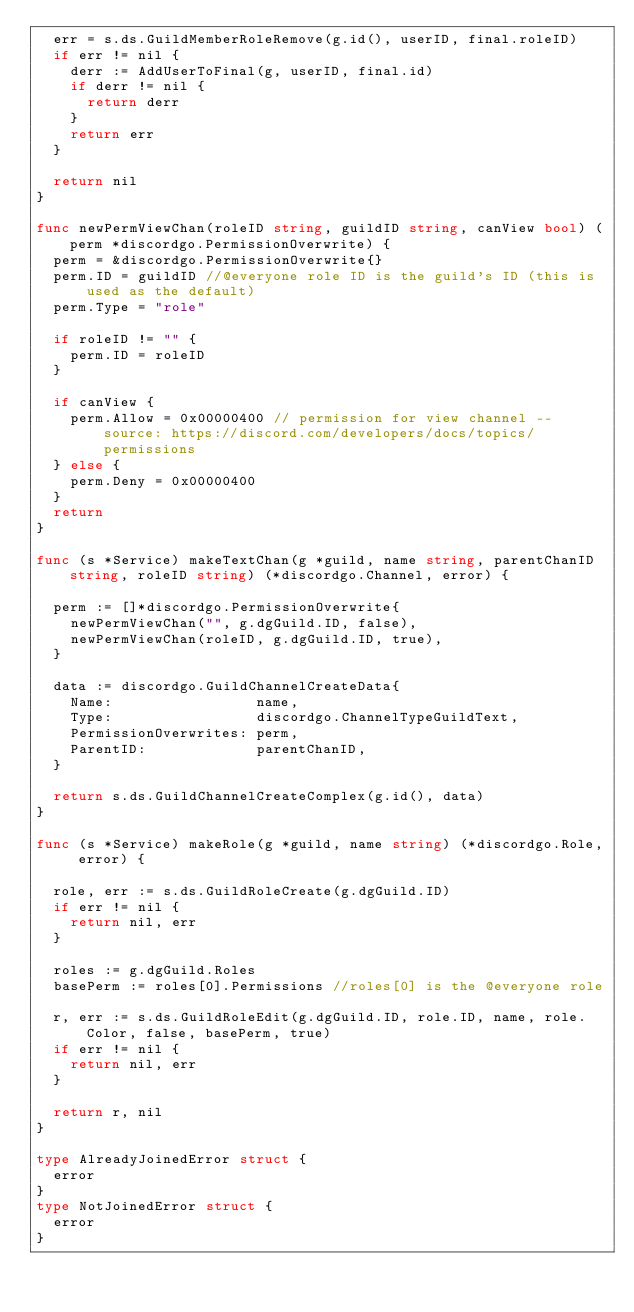Convert code to text. <code><loc_0><loc_0><loc_500><loc_500><_Go_>	err = s.ds.GuildMemberRoleRemove(g.id(), userID, final.roleID)
	if err != nil {
		derr := AddUserToFinal(g, userID, final.id)
		if derr != nil {
			return derr
		}
		return err
	}

	return nil
}

func newPermViewChan(roleID string, guildID string, canView bool) (perm *discordgo.PermissionOverwrite) {
	perm = &discordgo.PermissionOverwrite{}
	perm.ID = guildID //@everyone role ID is the guild's ID (this is used as the default)
	perm.Type = "role"

	if roleID != "" {
		perm.ID = roleID
	}

	if canView {
		perm.Allow = 0x00000400 // permission for view channel -- source: https://discord.com/developers/docs/topics/permissions
	} else {
		perm.Deny = 0x00000400
	}
	return
}

func (s *Service) makeTextChan(g *guild, name string, parentChanID string, roleID string) (*discordgo.Channel, error) {

	perm := []*discordgo.PermissionOverwrite{
		newPermViewChan("", g.dgGuild.ID, false),
		newPermViewChan(roleID, g.dgGuild.ID, true),
	}

	data := discordgo.GuildChannelCreateData{
		Name:                 name,
		Type:                 discordgo.ChannelTypeGuildText,
		PermissionOverwrites: perm,
		ParentID:             parentChanID,
	}

	return s.ds.GuildChannelCreateComplex(g.id(), data)
}

func (s *Service) makeRole(g *guild, name string) (*discordgo.Role, error) {

	role, err := s.ds.GuildRoleCreate(g.dgGuild.ID)
	if err != nil {
		return nil, err
	}

	roles := g.dgGuild.Roles
	basePerm := roles[0].Permissions //roles[0] is the @everyone role

	r, err := s.ds.GuildRoleEdit(g.dgGuild.ID, role.ID, name, role.Color, false, basePerm, true)
	if err != nil {
		return nil, err
	}

	return r, nil
}

type AlreadyJoinedError struct {
	error
}
type NotJoinedError struct {
	error
}
</code> 